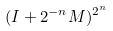<formula> <loc_0><loc_0><loc_500><loc_500>( I + 2 ^ { - n } M ) ^ { 2 ^ { n } }</formula> 